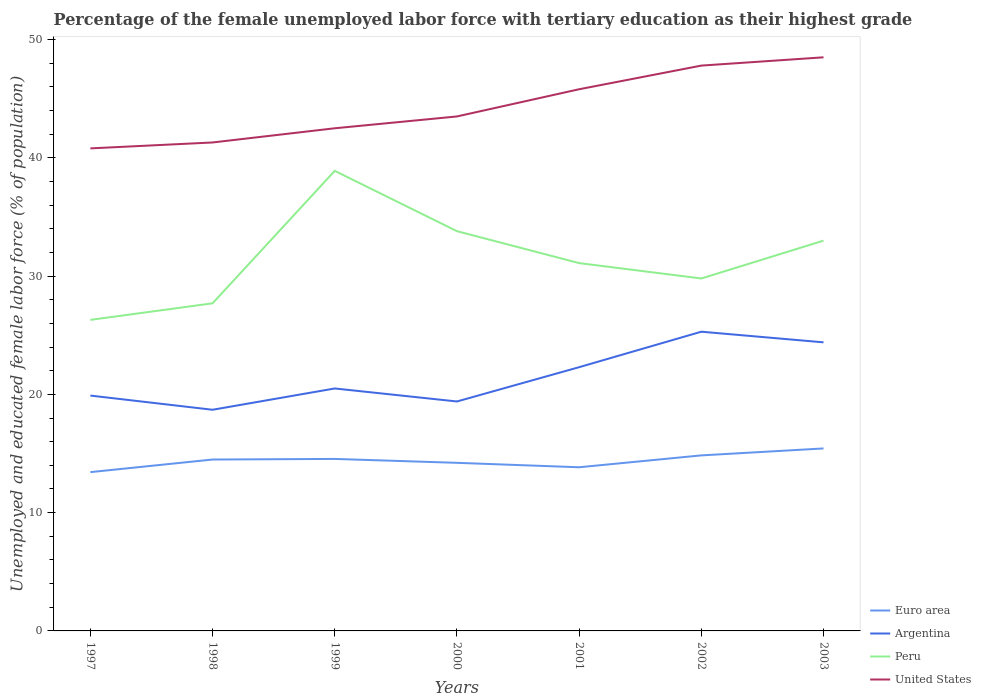How many different coloured lines are there?
Give a very brief answer. 4. Does the line corresponding to Peru intersect with the line corresponding to Argentina?
Your response must be concise. No. Across all years, what is the maximum percentage of the unemployed female labor force with tertiary education in Peru?
Make the answer very short. 26.3. In which year was the percentage of the unemployed female labor force with tertiary education in United States maximum?
Make the answer very short. 1997. What is the total percentage of the unemployed female labor force with tertiary education in Peru in the graph?
Provide a succinct answer. -3.2. What is the difference between the highest and the second highest percentage of the unemployed female labor force with tertiary education in Peru?
Your answer should be compact. 12.6. What is the difference between the highest and the lowest percentage of the unemployed female labor force with tertiary education in Argentina?
Provide a short and direct response. 3. How many lines are there?
Give a very brief answer. 4. How many years are there in the graph?
Ensure brevity in your answer.  7. How many legend labels are there?
Your response must be concise. 4. What is the title of the graph?
Your answer should be very brief. Percentage of the female unemployed labor force with tertiary education as their highest grade. Does "Tunisia" appear as one of the legend labels in the graph?
Give a very brief answer. No. What is the label or title of the X-axis?
Keep it short and to the point. Years. What is the label or title of the Y-axis?
Provide a succinct answer. Unemployed and educated female labor force (% of population). What is the Unemployed and educated female labor force (% of population) of Euro area in 1997?
Offer a very short reply. 13.43. What is the Unemployed and educated female labor force (% of population) of Argentina in 1997?
Provide a short and direct response. 19.9. What is the Unemployed and educated female labor force (% of population) of Peru in 1997?
Keep it short and to the point. 26.3. What is the Unemployed and educated female labor force (% of population) of United States in 1997?
Ensure brevity in your answer.  40.8. What is the Unemployed and educated female labor force (% of population) in Euro area in 1998?
Make the answer very short. 14.49. What is the Unemployed and educated female labor force (% of population) in Argentina in 1998?
Your response must be concise. 18.7. What is the Unemployed and educated female labor force (% of population) in Peru in 1998?
Your response must be concise. 27.7. What is the Unemployed and educated female labor force (% of population) in United States in 1998?
Provide a succinct answer. 41.3. What is the Unemployed and educated female labor force (% of population) of Euro area in 1999?
Offer a terse response. 14.54. What is the Unemployed and educated female labor force (% of population) in Peru in 1999?
Your answer should be compact. 38.9. What is the Unemployed and educated female labor force (% of population) in United States in 1999?
Keep it short and to the point. 42.5. What is the Unemployed and educated female labor force (% of population) in Euro area in 2000?
Ensure brevity in your answer.  14.21. What is the Unemployed and educated female labor force (% of population) of Argentina in 2000?
Provide a short and direct response. 19.4. What is the Unemployed and educated female labor force (% of population) in Peru in 2000?
Ensure brevity in your answer.  33.8. What is the Unemployed and educated female labor force (% of population) in United States in 2000?
Your answer should be very brief. 43.5. What is the Unemployed and educated female labor force (% of population) in Euro area in 2001?
Give a very brief answer. 13.84. What is the Unemployed and educated female labor force (% of population) in Argentina in 2001?
Offer a terse response. 22.3. What is the Unemployed and educated female labor force (% of population) of Peru in 2001?
Give a very brief answer. 31.1. What is the Unemployed and educated female labor force (% of population) of United States in 2001?
Your response must be concise. 45.8. What is the Unemployed and educated female labor force (% of population) in Euro area in 2002?
Make the answer very short. 14.84. What is the Unemployed and educated female labor force (% of population) in Argentina in 2002?
Give a very brief answer. 25.3. What is the Unemployed and educated female labor force (% of population) in Peru in 2002?
Offer a terse response. 29.8. What is the Unemployed and educated female labor force (% of population) in United States in 2002?
Provide a short and direct response. 47.8. What is the Unemployed and educated female labor force (% of population) in Euro area in 2003?
Provide a succinct answer. 15.43. What is the Unemployed and educated female labor force (% of population) of Argentina in 2003?
Provide a short and direct response. 24.4. What is the Unemployed and educated female labor force (% of population) of Peru in 2003?
Your response must be concise. 33. What is the Unemployed and educated female labor force (% of population) of United States in 2003?
Make the answer very short. 48.5. Across all years, what is the maximum Unemployed and educated female labor force (% of population) of Euro area?
Make the answer very short. 15.43. Across all years, what is the maximum Unemployed and educated female labor force (% of population) of Argentina?
Your response must be concise. 25.3. Across all years, what is the maximum Unemployed and educated female labor force (% of population) of Peru?
Provide a short and direct response. 38.9. Across all years, what is the maximum Unemployed and educated female labor force (% of population) in United States?
Give a very brief answer. 48.5. Across all years, what is the minimum Unemployed and educated female labor force (% of population) in Euro area?
Your response must be concise. 13.43. Across all years, what is the minimum Unemployed and educated female labor force (% of population) of Argentina?
Offer a very short reply. 18.7. Across all years, what is the minimum Unemployed and educated female labor force (% of population) of Peru?
Provide a short and direct response. 26.3. Across all years, what is the minimum Unemployed and educated female labor force (% of population) in United States?
Your answer should be compact. 40.8. What is the total Unemployed and educated female labor force (% of population) in Euro area in the graph?
Provide a succinct answer. 100.78. What is the total Unemployed and educated female labor force (% of population) in Argentina in the graph?
Ensure brevity in your answer.  150.5. What is the total Unemployed and educated female labor force (% of population) of Peru in the graph?
Provide a succinct answer. 220.6. What is the total Unemployed and educated female labor force (% of population) of United States in the graph?
Your response must be concise. 310.2. What is the difference between the Unemployed and educated female labor force (% of population) in Euro area in 1997 and that in 1998?
Give a very brief answer. -1.07. What is the difference between the Unemployed and educated female labor force (% of population) of Argentina in 1997 and that in 1998?
Offer a very short reply. 1.2. What is the difference between the Unemployed and educated female labor force (% of population) in United States in 1997 and that in 1998?
Make the answer very short. -0.5. What is the difference between the Unemployed and educated female labor force (% of population) of Euro area in 1997 and that in 1999?
Offer a very short reply. -1.12. What is the difference between the Unemployed and educated female labor force (% of population) in Peru in 1997 and that in 1999?
Ensure brevity in your answer.  -12.6. What is the difference between the Unemployed and educated female labor force (% of population) of United States in 1997 and that in 1999?
Ensure brevity in your answer.  -1.7. What is the difference between the Unemployed and educated female labor force (% of population) of Euro area in 1997 and that in 2000?
Provide a succinct answer. -0.79. What is the difference between the Unemployed and educated female labor force (% of population) in Argentina in 1997 and that in 2000?
Your answer should be very brief. 0.5. What is the difference between the Unemployed and educated female labor force (% of population) in Peru in 1997 and that in 2000?
Provide a short and direct response. -7.5. What is the difference between the Unemployed and educated female labor force (% of population) in Euro area in 1997 and that in 2001?
Offer a terse response. -0.41. What is the difference between the Unemployed and educated female labor force (% of population) of Argentina in 1997 and that in 2001?
Make the answer very short. -2.4. What is the difference between the Unemployed and educated female labor force (% of population) in Peru in 1997 and that in 2001?
Your answer should be compact. -4.8. What is the difference between the Unemployed and educated female labor force (% of population) of Euro area in 1997 and that in 2002?
Your response must be concise. -1.42. What is the difference between the Unemployed and educated female labor force (% of population) in Euro area in 1997 and that in 2003?
Provide a succinct answer. -2. What is the difference between the Unemployed and educated female labor force (% of population) in Argentina in 1997 and that in 2003?
Provide a short and direct response. -4.5. What is the difference between the Unemployed and educated female labor force (% of population) in Peru in 1997 and that in 2003?
Ensure brevity in your answer.  -6.7. What is the difference between the Unemployed and educated female labor force (% of population) in United States in 1997 and that in 2003?
Provide a short and direct response. -7.7. What is the difference between the Unemployed and educated female labor force (% of population) of Euro area in 1998 and that in 1999?
Give a very brief answer. -0.05. What is the difference between the Unemployed and educated female labor force (% of population) of Peru in 1998 and that in 1999?
Offer a terse response. -11.2. What is the difference between the Unemployed and educated female labor force (% of population) of Euro area in 1998 and that in 2000?
Give a very brief answer. 0.28. What is the difference between the Unemployed and educated female labor force (% of population) in Argentina in 1998 and that in 2000?
Keep it short and to the point. -0.7. What is the difference between the Unemployed and educated female labor force (% of population) of Euro area in 1998 and that in 2001?
Offer a terse response. 0.65. What is the difference between the Unemployed and educated female labor force (% of population) in Peru in 1998 and that in 2001?
Provide a short and direct response. -3.4. What is the difference between the Unemployed and educated female labor force (% of population) of Euro area in 1998 and that in 2002?
Your answer should be compact. -0.35. What is the difference between the Unemployed and educated female labor force (% of population) in Euro area in 1998 and that in 2003?
Offer a very short reply. -0.94. What is the difference between the Unemployed and educated female labor force (% of population) of Argentina in 1998 and that in 2003?
Your answer should be compact. -5.7. What is the difference between the Unemployed and educated female labor force (% of population) in United States in 1998 and that in 2003?
Keep it short and to the point. -7.2. What is the difference between the Unemployed and educated female labor force (% of population) of Euro area in 1999 and that in 2000?
Offer a terse response. 0.33. What is the difference between the Unemployed and educated female labor force (% of population) of Argentina in 1999 and that in 2000?
Your answer should be very brief. 1.1. What is the difference between the Unemployed and educated female labor force (% of population) in United States in 1999 and that in 2000?
Your response must be concise. -1. What is the difference between the Unemployed and educated female labor force (% of population) of Euro area in 1999 and that in 2001?
Provide a short and direct response. 0.71. What is the difference between the Unemployed and educated female labor force (% of population) in United States in 1999 and that in 2001?
Your answer should be very brief. -3.3. What is the difference between the Unemployed and educated female labor force (% of population) of Euro area in 1999 and that in 2002?
Your response must be concise. -0.3. What is the difference between the Unemployed and educated female labor force (% of population) of United States in 1999 and that in 2002?
Your answer should be compact. -5.3. What is the difference between the Unemployed and educated female labor force (% of population) in Euro area in 1999 and that in 2003?
Your answer should be compact. -0.89. What is the difference between the Unemployed and educated female labor force (% of population) of Peru in 1999 and that in 2003?
Offer a very short reply. 5.9. What is the difference between the Unemployed and educated female labor force (% of population) of United States in 1999 and that in 2003?
Make the answer very short. -6. What is the difference between the Unemployed and educated female labor force (% of population) in Euro area in 2000 and that in 2001?
Your answer should be very brief. 0.38. What is the difference between the Unemployed and educated female labor force (% of population) in United States in 2000 and that in 2001?
Offer a terse response. -2.3. What is the difference between the Unemployed and educated female labor force (% of population) in Euro area in 2000 and that in 2002?
Offer a very short reply. -0.63. What is the difference between the Unemployed and educated female labor force (% of population) in Euro area in 2000 and that in 2003?
Your response must be concise. -1.22. What is the difference between the Unemployed and educated female labor force (% of population) in Peru in 2000 and that in 2003?
Provide a succinct answer. 0.8. What is the difference between the Unemployed and educated female labor force (% of population) in Euro area in 2001 and that in 2002?
Provide a succinct answer. -1. What is the difference between the Unemployed and educated female labor force (% of population) in Argentina in 2001 and that in 2002?
Keep it short and to the point. -3. What is the difference between the Unemployed and educated female labor force (% of population) in Euro area in 2001 and that in 2003?
Provide a short and direct response. -1.59. What is the difference between the Unemployed and educated female labor force (% of population) in United States in 2001 and that in 2003?
Provide a succinct answer. -2.7. What is the difference between the Unemployed and educated female labor force (% of population) of Euro area in 2002 and that in 2003?
Make the answer very short. -0.59. What is the difference between the Unemployed and educated female labor force (% of population) in Argentina in 2002 and that in 2003?
Offer a terse response. 0.9. What is the difference between the Unemployed and educated female labor force (% of population) in Peru in 2002 and that in 2003?
Ensure brevity in your answer.  -3.2. What is the difference between the Unemployed and educated female labor force (% of population) in United States in 2002 and that in 2003?
Ensure brevity in your answer.  -0.7. What is the difference between the Unemployed and educated female labor force (% of population) of Euro area in 1997 and the Unemployed and educated female labor force (% of population) of Argentina in 1998?
Offer a terse response. -5.27. What is the difference between the Unemployed and educated female labor force (% of population) of Euro area in 1997 and the Unemployed and educated female labor force (% of population) of Peru in 1998?
Your answer should be compact. -14.27. What is the difference between the Unemployed and educated female labor force (% of population) in Euro area in 1997 and the Unemployed and educated female labor force (% of population) in United States in 1998?
Make the answer very short. -27.87. What is the difference between the Unemployed and educated female labor force (% of population) in Argentina in 1997 and the Unemployed and educated female labor force (% of population) in United States in 1998?
Provide a short and direct response. -21.4. What is the difference between the Unemployed and educated female labor force (% of population) of Euro area in 1997 and the Unemployed and educated female labor force (% of population) of Argentina in 1999?
Provide a short and direct response. -7.07. What is the difference between the Unemployed and educated female labor force (% of population) of Euro area in 1997 and the Unemployed and educated female labor force (% of population) of Peru in 1999?
Make the answer very short. -25.47. What is the difference between the Unemployed and educated female labor force (% of population) in Euro area in 1997 and the Unemployed and educated female labor force (% of population) in United States in 1999?
Your answer should be compact. -29.07. What is the difference between the Unemployed and educated female labor force (% of population) in Argentina in 1997 and the Unemployed and educated female labor force (% of population) in Peru in 1999?
Your answer should be very brief. -19. What is the difference between the Unemployed and educated female labor force (% of population) in Argentina in 1997 and the Unemployed and educated female labor force (% of population) in United States in 1999?
Keep it short and to the point. -22.6. What is the difference between the Unemployed and educated female labor force (% of population) of Peru in 1997 and the Unemployed and educated female labor force (% of population) of United States in 1999?
Provide a short and direct response. -16.2. What is the difference between the Unemployed and educated female labor force (% of population) in Euro area in 1997 and the Unemployed and educated female labor force (% of population) in Argentina in 2000?
Offer a very short reply. -5.97. What is the difference between the Unemployed and educated female labor force (% of population) in Euro area in 1997 and the Unemployed and educated female labor force (% of population) in Peru in 2000?
Provide a short and direct response. -20.37. What is the difference between the Unemployed and educated female labor force (% of population) in Euro area in 1997 and the Unemployed and educated female labor force (% of population) in United States in 2000?
Provide a short and direct response. -30.07. What is the difference between the Unemployed and educated female labor force (% of population) of Argentina in 1997 and the Unemployed and educated female labor force (% of population) of Peru in 2000?
Provide a succinct answer. -13.9. What is the difference between the Unemployed and educated female labor force (% of population) in Argentina in 1997 and the Unemployed and educated female labor force (% of population) in United States in 2000?
Keep it short and to the point. -23.6. What is the difference between the Unemployed and educated female labor force (% of population) in Peru in 1997 and the Unemployed and educated female labor force (% of population) in United States in 2000?
Offer a very short reply. -17.2. What is the difference between the Unemployed and educated female labor force (% of population) in Euro area in 1997 and the Unemployed and educated female labor force (% of population) in Argentina in 2001?
Give a very brief answer. -8.87. What is the difference between the Unemployed and educated female labor force (% of population) of Euro area in 1997 and the Unemployed and educated female labor force (% of population) of Peru in 2001?
Your answer should be compact. -17.67. What is the difference between the Unemployed and educated female labor force (% of population) of Euro area in 1997 and the Unemployed and educated female labor force (% of population) of United States in 2001?
Provide a succinct answer. -32.37. What is the difference between the Unemployed and educated female labor force (% of population) in Argentina in 1997 and the Unemployed and educated female labor force (% of population) in Peru in 2001?
Give a very brief answer. -11.2. What is the difference between the Unemployed and educated female labor force (% of population) in Argentina in 1997 and the Unemployed and educated female labor force (% of population) in United States in 2001?
Your response must be concise. -25.9. What is the difference between the Unemployed and educated female labor force (% of population) of Peru in 1997 and the Unemployed and educated female labor force (% of population) of United States in 2001?
Make the answer very short. -19.5. What is the difference between the Unemployed and educated female labor force (% of population) in Euro area in 1997 and the Unemployed and educated female labor force (% of population) in Argentina in 2002?
Your answer should be very brief. -11.87. What is the difference between the Unemployed and educated female labor force (% of population) in Euro area in 1997 and the Unemployed and educated female labor force (% of population) in Peru in 2002?
Provide a short and direct response. -16.37. What is the difference between the Unemployed and educated female labor force (% of population) in Euro area in 1997 and the Unemployed and educated female labor force (% of population) in United States in 2002?
Offer a very short reply. -34.37. What is the difference between the Unemployed and educated female labor force (% of population) in Argentina in 1997 and the Unemployed and educated female labor force (% of population) in Peru in 2002?
Provide a succinct answer. -9.9. What is the difference between the Unemployed and educated female labor force (% of population) of Argentina in 1997 and the Unemployed and educated female labor force (% of population) of United States in 2002?
Provide a short and direct response. -27.9. What is the difference between the Unemployed and educated female labor force (% of population) in Peru in 1997 and the Unemployed and educated female labor force (% of population) in United States in 2002?
Your answer should be compact. -21.5. What is the difference between the Unemployed and educated female labor force (% of population) of Euro area in 1997 and the Unemployed and educated female labor force (% of population) of Argentina in 2003?
Provide a short and direct response. -10.97. What is the difference between the Unemployed and educated female labor force (% of population) of Euro area in 1997 and the Unemployed and educated female labor force (% of population) of Peru in 2003?
Offer a terse response. -19.57. What is the difference between the Unemployed and educated female labor force (% of population) of Euro area in 1997 and the Unemployed and educated female labor force (% of population) of United States in 2003?
Make the answer very short. -35.07. What is the difference between the Unemployed and educated female labor force (% of population) in Argentina in 1997 and the Unemployed and educated female labor force (% of population) in United States in 2003?
Offer a very short reply. -28.6. What is the difference between the Unemployed and educated female labor force (% of population) in Peru in 1997 and the Unemployed and educated female labor force (% of population) in United States in 2003?
Offer a terse response. -22.2. What is the difference between the Unemployed and educated female labor force (% of population) in Euro area in 1998 and the Unemployed and educated female labor force (% of population) in Argentina in 1999?
Keep it short and to the point. -6.01. What is the difference between the Unemployed and educated female labor force (% of population) of Euro area in 1998 and the Unemployed and educated female labor force (% of population) of Peru in 1999?
Keep it short and to the point. -24.41. What is the difference between the Unemployed and educated female labor force (% of population) of Euro area in 1998 and the Unemployed and educated female labor force (% of population) of United States in 1999?
Your response must be concise. -28.01. What is the difference between the Unemployed and educated female labor force (% of population) of Argentina in 1998 and the Unemployed and educated female labor force (% of population) of Peru in 1999?
Make the answer very short. -20.2. What is the difference between the Unemployed and educated female labor force (% of population) of Argentina in 1998 and the Unemployed and educated female labor force (% of population) of United States in 1999?
Your response must be concise. -23.8. What is the difference between the Unemployed and educated female labor force (% of population) in Peru in 1998 and the Unemployed and educated female labor force (% of population) in United States in 1999?
Provide a succinct answer. -14.8. What is the difference between the Unemployed and educated female labor force (% of population) in Euro area in 1998 and the Unemployed and educated female labor force (% of population) in Argentina in 2000?
Provide a succinct answer. -4.91. What is the difference between the Unemployed and educated female labor force (% of population) in Euro area in 1998 and the Unemployed and educated female labor force (% of population) in Peru in 2000?
Your answer should be very brief. -19.31. What is the difference between the Unemployed and educated female labor force (% of population) in Euro area in 1998 and the Unemployed and educated female labor force (% of population) in United States in 2000?
Offer a terse response. -29.01. What is the difference between the Unemployed and educated female labor force (% of population) in Argentina in 1998 and the Unemployed and educated female labor force (% of population) in Peru in 2000?
Ensure brevity in your answer.  -15.1. What is the difference between the Unemployed and educated female labor force (% of population) of Argentina in 1998 and the Unemployed and educated female labor force (% of population) of United States in 2000?
Offer a very short reply. -24.8. What is the difference between the Unemployed and educated female labor force (% of population) of Peru in 1998 and the Unemployed and educated female labor force (% of population) of United States in 2000?
Your answer should be compact. -15.8. What is the difference between the Unemployed and educated female labor force (% of population) of Euro area in 1998 and the Unemployed and educated female labor force (% of population) of Argentina in 2001?
Your answer should be compact. -7.81. What is the difference between the Unemployed and educated female labor force (% of population) of Euro area in 1998 and the Unemployed and educated female labor force (% of population) of Peru in 2001?
Your response must be concise. -16.61. What is the difference between the Unemployed and educated female labor force (% of population) in Euro area in 1998 and the Unemployed and educated female labor force (% of population) in United States in 2001?
Keep it short and to the point. -31.31. What is the difference between the Unemployed and educated female labor force (% of population) of Argentina in 1998 and the Unemployed and educated female labor force (% of population) of United States in 2001?
Provide a succinct answer. -27.1. What is the difference between the Unemployed and educated female labor force (% of population) of Peru in 1998 and the Unemployed and educated female labor force (% of population) of United States in 2001?
Your response must be concise. -18.1. What is the difference between the Unemployed and educated female labor force (% of population) in Euro area in 1998 and the Unemployed and educated female labor force (% of population) in Argentina in 2002?
Make the answer very short. -10.81. What is the difference between the Unemployed and educated female labor force (% of population) of Euro area in 1998 and the Unemployed and educated female labor force (% of population) of Peru in 2002?
Provide a succinct answer. -15.31. What is the difference between the Unemployed and educated female labor force (% of population) of Euro area in 1998 and the Unemployed and educated female labor force (% of population) of United States in 2002?
Provide a short and direct response. -33.31. What is the difference between the Unemployed and educated female labor force (% of population) of Argentina in 1998 and the Unemployed and educated female labor force (% of population) of United States in 2002?
Provide a succinct answer. -29.1. What is the difference between the Unemployed and educated female labor force (% of population) in Peru in 1998 and the Unemployed and educated female labor force (% of population) in United States in 2002?
Ensure brevity in your answer.  -20.1. What is the difference between the Unemployed and educated female labor force (% of population) of Euro area in 1998 and the Unemployed and educated female labor force (% of population) of Argentina in 2003?
Your answer should be compact. -9.91. What is the difference between the Unemployed and educated female labor force (% of population) of Euro area in 1998 and the Unemployed and educated female labor force (% of population) of Peru in 2003?
Keep it short and to the point. -18.51. What is the difference between the Unemployed and educated female labor force (% of population) in Euro area in 1998 and the Unemployed and educated female labor force (% of population) in United States in 2003?
Your answer should be very brief. -34.01. What is the difference between the Unemployed and educated female labor force (% of population) in Argentina in 1998 and the Unemployed and educated female labor force (% of population) in Peru in 2003?
Offer a terse response. -14.3. What is the difference between the Unemployed and educated female labor force (% of population) in Argentina in 1998 and the Unemployed and educated female labor force (% of population) in United States in 2003?
Offer a terse response. -29.8. What is the difference between the Unemployed and educated female labor force (% of population) in Peru in 1998 and the Unemployed and educated female labor force (% of population) in United States in 2003?
Offer a terse response. -20.8. What is the difference between the Unemployed and educated female labor force (% of population) of Euro area in 1999 and the Unemployed and educated female labor force (% of population) of Argentina in 2000?
Offer a very short reply. -4.86. What is the difference between the Unemployed and educated female labor force (% of population) of Euro area in 1999 and the Unemployed and educated female labor force (% of population) of Peru in 2000?
Give a very brief answer. -19.26. What is the difference between the Unemployed and educated female labor force (% of population) of Euro area in 1999 and the Unemployed and educated female labor force (% of population) of United States in 2000?
Offer a terse response. -28.96. What is the difference between the Unemployed and educated female labor force (% of population) of Argentina in 1999 and the Unemployed and educated female labor force (% of population) of Peru in 2000?
Ensure brevity in your answer.  -13.3. What is the difference between the Unemployed and educated female labor force (% of population) in Argentina in 1999 and the Unemployed and educated female labor force (% of population) in United States in 2000?
Keep it short and to the point. -23. What is the difference between the Unemployed and educated female labor force (% of population) of Euro area in 1999 and the Unemployed and educated female labor force (% of population) of Argentina in 2001?
Offer a terse response. -7.76. What is the difference between the Unemployed and educated female labor force (% of population) of Euro area in 1999 and the Unemployed and educated female labor force (% of population) of Peru in 2001?
Your answer should be compact. -16.56. What is the difference between the Unemployed and educated female labor force (% of population) in Euro area in 1999 and the Unemployed and educated female labor force (% of population) in United States in 2001?
Keep it short and to the point. -31.26. What is the difference between the Unemployed and educated female labor force (% of population) of Argentina in 1999 and the Unemployed and educated female labor force (% of population) of United States in 2001?
Your response must be concise. -25.3. What is the difference between the Unemployed and educated female labor force (% of population) of Euro area in 1999 and the Unemployed and educated female labor force (% of population) of Argentina in 2002?
Ensure brevity in your answer.  -10.76. What is the difference between the Unemployed and educated female labor force (% of population) of Euro area in 1999 and the Unemployed and educated female labor force (% of population) of Peru in 2002?
Make the answer very short. -15.26. What is the difference between the Unemployed and educated female labor force (% of population) of Euro area in 1999 and the Unemployed and educated female labor force (% of population) of United States in 2002?
Offer a terse response. -33.26. What is the difference between the Unemployed and educated female labor force (% of population) of Argentina in 1999 and the Unemployed and educated female labor force (% of population) of Peru in 2002?
Your answer should be compact. -9.3. What is the difference between the Unemployed and educated female labor force (% of population) in Argentina in 1999 and the Unemployed and educated female labor force (% of population) in United States in 2002?
Offer a terse response. -27.3. What is the difference between the Unemployed and educated female labor force (% of population) in Peru in 1999 and the Unemployed and educated female labor force (% of population) in United States in 2002?
Keep it short and to the point. -8.9. What is the difference between the Unemployed and educated female labor force (% of population) of Euro area in 1999 and the Unemployed and educated female labor force (% of population) of Argentina in 2003?
Give a very brief answer. -9.86. What is the difference between the Unemployed and educated female labor force (% of population) of Euro area in 1999 and the Unemployed and educated female labor force (% of population) of Peru in 2003?
Offer a terse response. -18.46. What is the difference between the Unemployed and educated female labor force (% of population) in Euro area in 1999 and the Unemployed and educated female labor force (% of population) in United States in 2003?
Your response must be concise. -33.96. What is the difference between the Unemployed and educated female labor force (% of population) in Argentina in 1999 and the Unemployed and educated female labor force (% of population) in United States in 2003?
Provide a succinct answer. -28. What is the difference between the Unemployed and educated female labor force (% of population) in Euro area in 2000 and the Unemployed and educated female labor force (% of population) in Argentina in 2001?
Make the answer very short. -8.09. What is the difference between the Unemployed and educated female labor force (% of population) in Euro area in 2000 and the Unemployed and educated female labor force (% of population) in Peru in 2001?
Offer a terse response. -16.89. What is the difference between the Unemployed and educated female labor force (% of population) of Euro area in 2000 and the Unemployed and educated female labor force (% of population) of United States in 2001?
Your response must be concise. -31.59. What is the difference between the Unemployed and educated female labor force (% of population) of Argentina in 2000 and the Unemployed and educated female labor force (% of population) of Peru in 2001?
Offer a terse response. -11.7. What is the difference between the Unemployed and educated female labor force (% of population) in Argentina in 2000 and the Unemployed and educated female labor force (% of population) in United States in 2001?
Your answer should be compact. -26.4. What is the difference between the Unemployed and educated female labor force (% of population) in Euro area in 2000 and the Unemployed and educated female labor force (% of population) in Argentina in 2002?
Keep it short and to the point. -11.09. What is the difference between the Unemployed and educated female labor force (% of population) in Euro area in 2000 and the Unemployed and educated female labor force (% of population) in Peru in 2002?
Provide a succinct answer. -15.59. What is the difference between the Unemployed and educated female labor force (% of population) of Euro area in 2000 and the Unemployed and educated female labor force (% of population) of United States in 2002?
Offer a terse response. -33.59. What is the difference between the Unemployed and educated female labor force (% of population) in Argentina in 2000 and the Unemployed and educated female labor force (% of population) in Peru in 2002?
Offer a very short reply. -10.4. What is the difference between the Unemployed and educated female labor force (% of population) of Argentina in 2000 and the Unemployed and educated female labor force (% of population) of United States in 2002?
Offer a terse response. -28.4. What is the difference between the Unemployed and educated female labor force (% of population) in Euro area in 2000 and the Unemployed and educated female labor force (% of population) in Argentina in 2003?
Your response must be concise. -10.19. What is the difference between the Unemployed and educated female labor force (% of population) of Euro area in 2000 and the Unemployed and educated female labor force (% of population) of Peru in 2003?
Your answer should be very brief. -18.79. What is the difference between the Unemployed and educated female labor force (% of population) in Euro area in 2000 and the Unemployed and educated female labor force (% of population) in United States in 2003?
Ensure brevity in your answer.  -34.29. What is the difference between the Unemployed and educated female labor force (% of population) of Argentina in 2000 and the Unemployed and educated female labor force (% of population) of Peru in 2003?
Offer a terse response. -13.6. What is the difference between the Unemployed and educated female labor force (% of population) in Argentina in 2000 and the Unemployed and educated female labor force (% of population) in United States in 2003?
Offer a very short reply. -29.1. What is the difference between the Unemployed and educated female labor force (% of population) in Peru in 2000 and the Unemployed and educated female labor force (% of population) in United States in 2003?
Offer a very short reply. -14.7. What is the difference between the Unemployed and educated female labor force (% of population) in Euro area in 2001 and the Unemployed and educated female labor force (% of population) in Argentina in 2002?
Make the answer very short. -11.46. What is the difference between the Unemployed and educated female labor force (% of population) in Euro area in 2001 and the Unemployed and educated female labor force (% of population) in Peru in 2002?
Make the answer very short. -15.96. What is the difference between the Unemployed and educated female labor force (% of population) in Euro area in 2001 and the Unemployed and educated female labor force (% of population) in United States in 2002?
Your answer should be compact. -33.96. What is the difference between the Unemployed and educated female labor force (% of population) of Argentina in 2001 and the Unemployed and educated female labor force (% of population) of United States in 2002?
Provide a short and direct response. -25.5. What is the difference between the Unemployed and educated female labor force (% of population) in Peru in 2001 and the Unemployed and educated female labor force (% of population) in United States in 2002?
Provide a short and direct response. -16.7. What is the difference between the Unemployed and educated female labor force (% of population) of Euro area in 2001 and the Unemployed and educated female labor force (% of population) of Argentina in 2003?
Offer a very short reply. -10.56. What is the difference between the Unemployed and educated female labor force (% of population) in Euro area in 2001 and the Unemployed and educated female labor force (% of population) in Peru in 2003?
Your response must be concise. -19.16. What is the difference between the Unemployed and educated female labor force (% of population) in Euro area in 2001 and the Unemployed and educated female labor force (% of population) in United States in 2003?
Ensure brevity in your answer.  -34.66. What is the difference between the Unemployed and educated female labor force (% of population) in Argentina in 2001 and the Unemployed and educated female labor force (% of population) in Peru in 2003?
Your answer should be very brief. -10.7. What is the difference between the Unemployed and educated female labor force (% of population) in Argentina in 2001 and the Unemployed and educated female labor force (% of population) in United States in 2003?
Your response must be concise. -26.2. What is the difference between the Unemployed and educated female labor force (% of population) of Peru in 2001 and the Unemployed and educated female labor force (% of population) of United States in 2003?
Offer a very short reply. -17.4. What is the difference between the Unemployed and educated female labor force (% of population) in Euro area in 2002 and the Unemployed and educated female labor force (% of population) in Argentina in 2003?
Your response must be concise. -9.56. What is the difference between the Unemployed and educated female labor force (% of population) in Euro area in 2002 and the Unemployed and educated female labor force (% of population) in Peru in 2003?
Offer a very short reply. -18.16. What is the difference between the Unemployed and educated female labor force (% of population) of Euro area in 2002 and the Unemployed and educated female labor force (% of population) of United States in 2003?
Ensure brevity in your answer.  -33.66. What is the difference between the Unemployed and educated female labor force (% of population) of Argentina in 2002 and the Unemployed and educated female labor force (% of population) of United States in 2003?
Your response must be concise. -23.2. What is the difference between the Unemployed and educated female labor force (% of population) of Peru in 2002 and the Unemployed and educated female labor force (% of population) of United States in 2003?
Provide a short and direct response. -18.7. What is the average Unemployed and educated female labor force (% of population) of Euro area per year?
Your response must be concise. 14.4. What is the average Unemployed and educated female labor force (% of population) in Argentina per year?
Keep it short and to the point. 21.5. What is the average Unemployed and educated female labor force (% of population) of Peru per year?
Provide a succinct answer. 31.51. What is the average Unemployed and educated female labor force (% of population) of United States per year?
Your answer should be compact. 44.31. In the year 1997, what is the difference between the Unemployed and educated female labor force (% of population) of Euro area and Unemployed and educated female labor force (% of population) of Argentina?
Make the answer very short. -6.47. In the year 1997, what is the difference between the Unemployed and educated female labor force (% of population) of Euro area and Unemployed and educated female labor force (% of population) of Peru?
Make the answer very short. -12.87. In the year 1997, what is the difference between the Unemployed and educated female labor force (% of population) of Euro area and Unemployed and educated female labor force (% of population) of United States?
Your response must be concise. -27.37. In the year 1997, what is the difference between the Unemployed and educated female labor force (% of population) of Argentina and Unemployed and educated female labor force (% of population) of United States?
Offer a terse response. -20.9. In the year 1998, what is the difference between the Unemployed and educated female labor force (% of population) in Euro area and Unemployed and educated female labor force (% of population) in Argentina?
Make the answer very short. -4.21. In the year 1998, what is the difference between the Unemployed and educated female labor force (% of population) in Euro area and Unemployed and educated female labor force (% of population) in Peru?
Keep it short and to the point. -13.21. In the year 1998, what is the difference between the Unemployed and educated female labor force (% of population) of Euro area and Unemployed and educated female labor force (% of population) of United States?
Ensure brevity in your answer.  -26.81. In the year 1998, what is the difference between the Unemployed and educated female labor force (% of population) in Argentina and Unemployed and educated female labor force (% of population) in United States?
Provide a succinct answer. -22.6. In the year 1999, what is the difference between the Unemployed and educated female labor force (% of population) in Euro area and Unemployed and educated female labor force (% of population) in Argentina?
Your answer should be compact. -5.96. In the year 1999, what is the difference between the Unemployed and educated female labor force (% of population) in Euro area and Unemployed and educated female labor force (% of population) in Peru?
Your answer should be very brief. -24.36. In the year 1999, what is the difference between the Unemployed and educated female labor force (% of population) in Euro area and Unemployed and educated female labor force (% of population) in United States?
Offer a very short reply. -27.96. In the year 1999, what is the difference between the Unemployed and educated female labor force (% of population) in Argentina and Unemployed and educated female labor force (% of population) in Peru?
Keep it short and to the point. -18.4. In the year 1999, what is the difference between the Unemployed and educated female labor force (% of population) in Argentina and Unemployed and educated female labor force (% of population) in United States?
Give a very brief answer. -22. In the year 2000, what is the difference between the Unemployed and educated female labor force (% of population) of Euro area and Unemployed and educated female labor force (% of population) of Argentina?
Offer a very short reply. -5.19. In the year 2000, what is the difference between the Unemployed and educated female labor force (% of population) of Euro area and Unemployed and educated female labor force (% of population) of Peru?
Provide a short and direct response. -19.59. In the year 2000, what is the difference between the Unemployed and educated female labor force (% of population) of Euro area and Unemployed and educated female labor force (% of population) of United States?
Offer a terse response. -29.29. In the year 2000, what is the difference between the Unemployed and educated female labor force (% of population) of Argentina and Unemployed and educated female labor force (% of population) of Peru?
Ensure brevity in your answer.  -14.4. In the year 2000, what is the difference between the Unemployed and educated female labor force (% of population) in Argentina and Unemployed and educated female labor force (% of population) in United States?
Your answer should be compact. -24.1. In the year 2001, what is the difference between the Unemployed and educated female labor force (% of population) of Euro area and Unemployed and educated female labor force (% of population) of Argentina?
Offer a very short reply. -8.46. In the year 2001, what is the difference between the Unemployed and educated female labor force (% of population) in Euro area and Unemployed and educated female labor force (% of population) in Peru?
Make the answer very short. -17.26. In the year 2001, what is the difference between the Unemployed and educated female labor force (% of population) in Euro area and Unemployed and educated female labor force (% of population) in United States?
Ensure brevity in your answer.  -31.96. In the year 2001, what is the difference between the Unemployed and educated female labor force (% of population) in Argentina and Unemployed and educated female labor force (% of population) in United States?
Your answer should be very brief. -23.5. In the year 2001, what is the difference between the Unemployed and educated female labor force (% of population) in Peru and Unemployed and educated female labor force (% of population) in United States?
Offer a very short reply. -14.7. In the year 2002, what is the difference between the Unemployed and educated female labor force (% of population) of Euro area and Unemployed and educated female labor force (% of population) of Argentina?
Your answer should be very brief. -10.46. In the year 2002, what is the difference between the Unemployed and educated female labor force (% of population) in Euro area and Unemployed and educated female labor force (% of population) in Peru?
Ensure brevity in your answer.  -14.96. In the year 2002, what is the difference between the Unemployed and educated female labor force (% of population) of Euro area and Unemployed and educated female labor force (% of population) of United States?
Provide a succinct answer. -32.96. In the year 2002, what is the difference between the Unemployed and educated female labor force (% of population) in Argentina and Unemployed and educated female labor force (% of population) in United States?
Provide a short and direct response. -22.5. In the year 2003, what is the difference between the Unemployed and educated female labor force (% of population) of Euro area and Unemployed and educated female labor force (% of population) of Argentina?
Keep it short and to the point. -8.97. In the year 2003, what is the difference between the Unemployed and educated female labor force (% of population) of Euro area and Unemployed and educated female labor force (% of population) of Peru?
Your answer should be very brief. -17.57. In the year 2003, what is the difference between the Unemployed and educated female labor force (% of population) of Euro area and Unemployed and educated female labor force (% of population) of United States?
Your answer should be compact. -33.07. In the year 2003, what is the difference between the Unemployed and educated female labor force (% of population) of Argentina and Unemployed and educated female labor force (% of population) of Peru?
Offer a terse response. -8.6. In the year 2003, what is the difference between the Unemployed and educated female labor force (% of population) in Argentina and Unemployed and educated female labor force (% of population) in United States?
Provide a succinct answer. -24.1. In the year 2003, what is the difference between the Unemployed and educated female labor force (% of population) in Peru and Unemployed and educated female labor force (% of population) in United States?
Your answer should be compact. -15.5. What is the ratio of the Unemployed and educated female labor force (% of population) of Euro area in 1997 to that in 1998?
Your response must be concise. 0.93. What is the ratio of the Unemployed and educated female labor force (% of population) in Argentina in 1997 to that in 1998?
Ensure brevity in your answer.  1.06. What is the ratio of the Unemployed and educated female labor force (% of population) in Peru in 1997 to that in 1998?
Keep it short and to the point. 0.95. What is the ratio of the Unemployed and educated female labor force (% of population) of United States in 1997 to that in 1998?
Ensure brevity in your answer.  0.99. What is the ratio of the Unemployed and educated female labor force (% of population) in Euro area in 1997 to that in 1999?
Your answer should be very brief. 0.92. What is the ratio of the Unemployed and educated female labor force (% of population) of Argentina in 1997 to that in 1999?
Keep it short and to the point. 0.97. What is the ratio of the Unemployed and educated female labor force (% of population) of Peru in 1997 to that in 1999?
Offer a terse response. 0.68. What is the ratio of the Unemployed and educated female labor force (% of population) of Euro area in 1997 to that in 2000?
Ensure brevity in your answer.  0.94. What is the ratio of the Unemployed and educated female labor force (% of population) in Argentina in 1997 to that in 2000?
Make the answer very short. 1.03. What is the ratio of the Unemployed and educated female labor force (% of population) in Peru in 1997 to that in 2000?
Your response must be concise. 0.78. What is the ratio of the Unemployed and educated female labor force (% of population) in United States in 1997 to that in 2000?
Offer a terse response. 0.94. What is the ratio of the Unemployed and educated female labor force (% of population) of Euro area in 1997 to that in 2001?
Keep it short and to the point. 0.97. What is the ratio of the Unemployed and educated female labor force (% of population) of Argentina in 1997 to that in 2001?
Offer a terse response. 0.89. What is the ratio of the Unemployed and educated female labor force (% of population) of Peru in 1997 to that in 2001?
Offer a terse response. 0.85. What is the ratio of the Unemployed and educated female labor force (% of population) in United States in 1997 to that in 2001?
Provide a short and direct response. 0.89. What is the ratio of the Unemployed and educated female labor force (% of population) in Euro area in 1997 to that in 2002?
Your response must be concise. 0.9. What is the ratio of the Unemployed and educated female labor force (% of population) in Argentina in 1997 to that in 2002?
Your answer should be very brief. 0.79. What is the ratio of the Unemployed and educated female labor force (% of population) in Peru in 1997 to that in 2002?
Provide a short and direct response. 0.88. What is the ratio of the Unemployed and educated female labor force (% of population) in United States in 1997 to that in 2002?
Make the answer very short. 0.85. What is the ratio of the Unemployed and educated female labor force (% of population) in Euro area in 1997 to that in 2003?
Your answer should be very brief. 0.87. What is the ratio of the Unemployed and educated female labor force (% of population) in Argentina in 1997 to that in 2003?
Make the answer very short. 0.82. What is the ratio of the Unemployed and educated female labor force (% of population) of Peru in 1997 to that in 2003?
Your response must be concise. 0.8. What is the ratio of the Unemployed and educated female labor force (% of population) of United States in 1997 to that in 2003?
Make the answer very short. 0.84. What is the ratio of the Unemployed and educated female labor force (% of population) in Argentina in 1998 to that in 1999?
Provide a short and direct response. 0.91. What is the ratio of the Unemployed and educated female labor force (% of population) in Peru in 1998 to that in 1999?
Make the answer very short. 0.71. What is the ratio of the Unemployed and educated female labor force (% of population) in United States in 1998 to that in 1999?
Offer a terse response. 0.97. What is the ratio of the Unemployed and educated female labor force (% of population) in Euro area in 1998 to that in 2000?
Provide a succinct answer. 1.02. What is the ratio of the Unemployed and educated female labor force (% of population) in Argentina in 1998 to that in 2000?
Your response must be concise. 0.96. What is the ratio of the Unemployed and educated female labor force (% of population) in Peru in 1998 to that in 2000?
Ensure brevity in your answer.  0.82. What is the ratio of the Unemployed and educated female labor force (% of population) of United States in 1998 to that in 2000?
Offer a very short reply. 0.95. What is the ratio of the Unemployed and educated female labor force (% of population) in Euro area in 1998 to that in 2001?
Your response must be concise. 1.05. What is the ratio of the Unemployed and educated female labor force (% of population) in Argentina in 1998 to that in 2001?
Ensure brevity in your answer.  0.84. What is the ratio of the Unemployed and educated female labor force (% of population) in Peru in 1998 to that in 2001?
Ensure brevity in your answer.  0.89. What is the ratio of the Unemployed and educated female labor force (% of population) in United States in 1998 to that in 2001?
Keep it short and to the point. 0.9. What is the ratio of the Unemployed and educated female labor force (% of population) of Euro area in 1998 to that in 2002?
Give a very brief answer. 0.98. What is the ratio of the Unemployed and educated female labor force (% of population) in Argentina in 1998 to that in 2002?
Offer a terse response. 0.74. What is the ratio of the Unemployed and educated female labor force (% of population) in Peru in 1998 to that in 2002?
Your response must be concise. 0.93. What is the ratio of the Unemployed and educated female labor force (% of population) in United States in 1998 to that in 2002?
Offer a very short reply. 0.86. What is the ratio of the Unemployed and educated female labor force (% of population) of Euro area in 1998 to that in 2003?
Provide a short and direct response. 0.94. What is the ratio of the Unemployed and educated female labor force (% of population) in Argentina in 1998 to that in 2003?
Offer a very short reply. 0.77. What is the ratio of the Unemployed and educated female labor force (% of population) in Peru in 1998 to that in 2003?
Offer a very short reply. 0.84. What is the ratio of the Unemployed and educated female labor force (% of population) in United States in 1998 to that in 2003?
Keep it short and to the point. 0.85. What is the ratio of the Unemployed and educated female labor force (% of population) in Euro area in 1999 to that in 2000?
Give a very brief answer. 1.02. What is the ratio of the Unemployed and educated female labor force (% of population) in Argentina in 1999 to that in 2000?
Your answer should be compact. 1.06. What is the ratio of the Unemployed and educated female labor force (% of population) in Peru in 1999 to that in 2000?
Keep it short and to the point. 1.15. What is the ratio of the Unemployed and educated female labor force (% of population) of United States in 1999 to that in 2000?
Provide a short and direct response. 0.98. What is the ratio of the Unemployed and educated female labor force (% of population) of Euro area in 1999 to that in 2001?
Your response must be concise. 1.05. What is the ratio of the Unemployed and educated female labor force (% of population) in Argentina in 1999 to that in 2001?
Make the answer very short. 0.92. What is the ratio of the Unemployed and educated female labor force (% of population) in Peru in 1999 to that in 2001?
Provide a succinct answer. 1.25. What is the ratio of the Unemployed and educated female labor force (% of population) of United States in 1999 to that in 2001?
Offer a very short reply. 0.93. What is the ratio of the Unemployed and educated female labor force (% of population) in Euro area in 1999 to that in 2002?
Give a very brief answer. 0.98. What is the ratio of the Unemployed and educated female labor force (% of population) in Argentina in 1999 to that in 2002?
Your answer should be very brief. 0.81. What is the ratio of the Unemployed and educated female labor force (% of population) in Peru in 1999 to that in 2002?
Provide a short and direct response. 1.31. What is the ratio of the Unemployed and educated female labor force (% of population) of United States in 1999 to that in 2002?
Make the answer very short. 0.89. What is the ratio of the Unemployed and educated female labor force (% of population) in Euro area in 1999 to that in 2003?
Your response must be concise. 0.94. What is the ratio of the Unemployed and educated female labor force (% of population) in Argentina in 1999 to that in 2003?
Offer a terse response. 0.84. What is the ratio of the Unemployed and educated female labor force (% of population) of Peru in 1999 to that in 2003?
Your response must be concise. 1.18. What is the ratio of the Unemployed and educated female labor force (% of population) of United States in 1999 to that in 2003?
Offer a very short reply. 0.88. What is the ratio of the Unemployed and educated female labor force (% of population) of Euro area in 2000 to that in 2001?
Keep it short and to the point. 1.03. What is the ratio of the Unemployed and educated female labor force (% of population) of Argentina in 2000 to that in 2001?
Make the answer very short. 0.87. What is the ratio of the Unemployed and educated female labor force (% of population) in Peru in 2000 to that in 2001?
Provide a short and direct response. 1.09. What is the ratio of the Unemployed and educated female labor force (% of population) of United States in 2000 to that in 2001?
Keep it short and to the point. 0.95. What is the ratio of the Unemployed and educated female labor force (% of population) of Euro area in 2000 to that in 2002?
Provide a succinct answer. 0.96. What is the ratio of the Unemployed and educated female labor force (% of population) in Argentina in 2000 to that in 2002?
Ensure brevity in your answer.  0.77. What is the ratio of the Unemployed and educated female labor force (% of population) in Peru in 2000 to that in 2002?
Ensure brevity in your answer.  1.13. What is the ratio of the Unemployed and educated female labor force (% of population) of United States in 2000 to that in 2002?
Offer a very short reply. 0.91. What is the ratio of the Unemployed and educated female labor force (% of population) in Euro area in 2000 to that in 2003?
Make the answer very short. 0.92. What is the ratio of the Unemployed and educated female labor force (% of population) in Argentina in 2000 to that in 2003?
Offer a very short reply. 0.8. What is the ratio of the Unemployed and educated female labor force (% of population) of Peru in 2000 to that in 2003?
Your answer should be compact. 1.02. What is the ratio of the Unemployed and educated female labor force (% of population) of United States in 2000 to that in 2003?
Keep it short and to the point. 0.9. What is the ratio of the Unemployed and educated female labor force (% of population) of Euro area in 2001 to that in 2002?
Give a very brief answer. 0.93. What is the ratio of the Unemployed and educated female labor force (% of population) in Argentina in 2001 to that in 2002?
Give a very brief answer. 0.88. What is the ratio of the Unemployed and educated female labor force (% of population) in Peru in 2001 to that in 2002?
Provide a short and direct response. 1.04. What is the ratio of the Unemployed and educated female labor force (% of population) of United States in 2001 to that in 2002?
Offer a terse response. 0.96. What is the ratio of the Unemployed and educated female labor force (% of population) in Euro area in 2001 to that in 2003?
Give a very brief answer. 0.9. What is the ratio of the Unemployed and educated female labor force (% of population) in Argentina in 2001 to that in 2003?
Offer a very short reply. 0.91. What is the ratio of the Unemployed and educated female labor force (% of population) of Peru in 2001 to that in 2003?
Offer a very short reply. 0.94. What is the ratio of the Unemployed and educated female labor force (% of population) of United States in 2001 to that in 2003?
Offer a very short reply. 0.94. What is the ratio of the Unemployed and educated female labor force (% of population) in Euro area in 2002 to that in 2003?
Your answer should be very brief. 0.96. What is the ratio of the Unemployed and educated female labor force (% of population) of Argentina in 2002 to that in 2003?
Provide a short and direct response. 1.04. What is the ratio of the Unemployed and educated female labor force (% of population) in Peru in 2002 to that in 2003?
Keep it short and to the point. 0.9. What is the ratio of the Unemployed and educated female labor force (% of population) in United States in 2002 to that in 2003?
Your answer should be very brief. 0.99. What is the difference between the highest and the second highest Unemployed and educated female labor force (% of population) in Euro area?
Provide a short and direct response. 0.59. What is the difference between the highest and the second highest Unemployed and educated female labor force (% of population) in Argentina?
Your response must be concise. 0.9. What is the difference between the highest and the second highest Unemployed and educated female labor force (% of population) in United States?
Offer a very short reply. 0.7. What is the difference between the highest and the lowest Unemployed and educated female labor force (% of population) of Euro area?
Make the answer very short. 2. What is the difference between the highest and the lowest Unemployed and educated female labor force (% of population) of Argentina?
Keep it short and to the point. 6.6. 